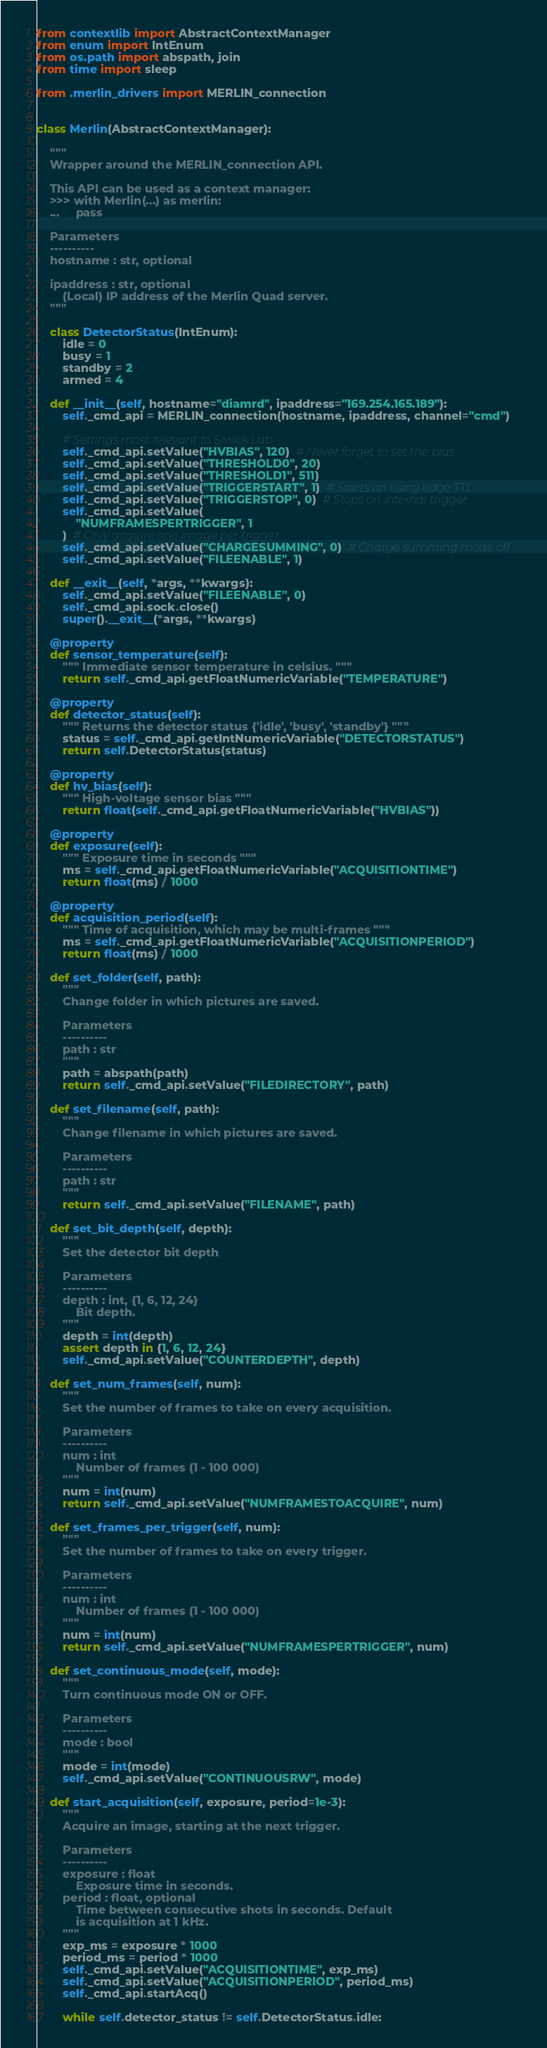<code> <loc_0><loc_0><loc_500><loc_500><_Python_>from contextlib import AbstractContextManager
from enum import IntEnum
from os.path import abspath, join
from time import sleep

from .merlin_drivers import MERLIN_connection


class Merlin(AbstractContextManager):

    """
    Wrapper around the MERLIN_connection API.

    This API can be used as a context manager:
    >>> with Merlin(...) as merlin:
    ...     pass

    Parameters
    ----------
    hostname : str, optional
    
    ipaddress : str, optional
        (Local) IP address of the Merlin Quad server.
    """

    class DetectorStatus(IntEnum):
        idle = 0
        busy = 1
        standby = 2
        armed = 4

    def __init__(self, hostname="diamrd", ipaddress="169.254.165.189"):
        self._cmd_api = MERLIN_connection(hostname, ipaddress, channel="cmd")

        # Settings most relevant to Siwick Lab
        self._cmd_api.setValue("HVBIAS", 120)  # Never forget to set the bias
        self._cmd_api.setValue("THRESHOLD0", 20)
        self._cmd_api.setValue("THRESHOLD1", 511)
        self._cmd_api.setValue("TRIGGERSTART", 1)  # Starts on rising edge TTL
        self._cmd_api.setValue("TRIGGERSTOP", 0)  # Stops on internal trigger
        self._cmd_api.setValue(
            "NUMFRAMESPERTRIGGER", 1
        )  # Only acquire one image per trigger
        self._cmd_api.setValue("CHARGESUMMING", 0)  # Charge summing mode off
        self._cmd_api.setValue("FILEENABLE", 1)

    def __exit__(self, *args, **kwargs):
        self._cmd_api.setValue("FILEENABLE", 0)
        self._cmd_api.sock.close()
        super().__exit__(*args, **kwargs)

    @property
    def sensor_temperature(self):
        """ Immediate sensor temperature in celsius. """
        return self._cmd_api.getFloatNumericVariable("TEMPERATURE")

    @property
    def detector_status(self):
        """ Returns the detector status {'idle', 'busy', 'standby'} """
        status = self._cmd_api.getIntNumericVariable("DETECTORSTATUS")
        return self.DetectorStatus(status)

    @property
    def hv_bias(self):
        """ High-voltage sensor bias """
        return float(self._cmd_api.getFloatNumericVariable("HVBIAS"))

    @property
    def exposure(self):
        """ Exposure time in seconds """
        ms = self._cmd_api.getFloatNumericVariable("ACQUISITIONTIME")
        return float(ms) / 1000

    @property
    def acquisition_period(self):
        """ Time of acquisition, which may be multi-frames """
        ms = self._cmd_api.getFloatNumericVariable("ACQUISITIONPERIOD")
        return float(ms) / 1000

    def set_folder(self, path):
        """ 
        Change folder in which pictures are saved.
        
        Parameters
        ----------
        path : str
        """
        path = abspath(path)
        return self._cmd_api.setValue("FILEDIRECTORY", path)

    def set_filename(self, path):
        """ 
        Change filename in which pictures are saved.
        
        Parameters
        ----------
        path : str
        """
        return self._cmd_api.setValue("FILENAME", path)

    def set_bit_depth(self, depth):
        """ 
        Set the detector bit depth

        Parameters
        ----------
        depth : int, {1, 6, 12, 24}
            Bit depth.
        """
        depth = int(depth)
        assert depth in {1, 6, 12, 24}
        self._cmd_api.setValue("COUNTERDEPTH", depth)

    def set_num_frames(self, num):
        """
        Set the number of frames to take on every acquisition.

        Parameters
        ----------
        num : int
            Number of frames (1 - 100 000)
        """
        num = int(num)
        return self._cmd_api.setValue("NUMFRAMESTOACQUIRE", num)

    def set_frames_per_trigger(self, num):
        """
        Set the number of frames to take on every trigger.

        Parameters
        ----------
        num : int
            Number of frames (1 - 100 000)
        """
        num = int(num)
        return self._cmd_api.setValue("NUMFRAMESPERTRIGGER", num)

    def set_continuous_mode(self, mode):
        """
        Turn continuous mode ON or OFF.

        Parameters
        ----------
        mode : bool
        """
        mode = int(mode)
        self._cmd_api.setValue("CONTINUOUSRW", mode)

    def start_acquisition(self, exposure, period=1e-3):
        """
        Acquire an image, starting at the next trigger. 

        Parameters
        ----------
        exposure : float
            Exposure time in seconds.
        period : float, optional
            Time between consecutive shots in seconds. Default
            is acquisition at 1 kHz.
        """
        exp_ms = exposure * 1000
        period_ms = period * 1000
        self._cmd_api.setValue("ACQUISITIONTIME", exp_ms)
        self._cmd_api.setValue("ACQUISITIONPERIOD", period_ms)
        self._cmd_api.startAcq()

        while self.detector_status != self.DetectorStatus.idle:</code> 